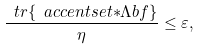<formula> <loc_0><loc_0><loc_500><loc_500>\frac { \ t r \{ \ a c c e n t s e t { \ast } { \Lambda b f } \} } { \eta } \leq \varepsilon ,</formula> 